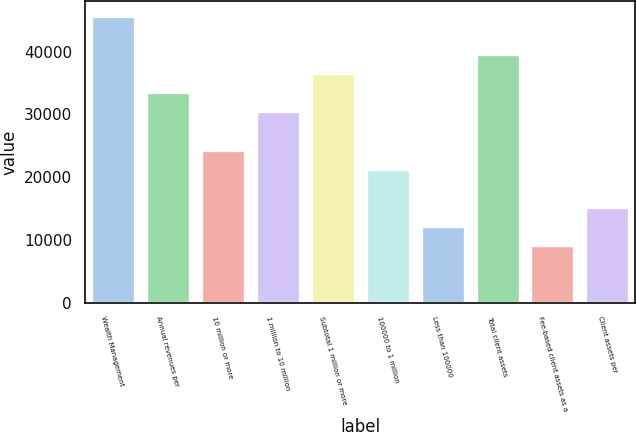<chart> <loc_0><loc_0><loc_500><loc_500><bar_chart><fcel>Wealth Management<fcel>Annual revenues per<fcel>10 million or more<fcel>1 million to 10 million<fcel>Subtotal 1 million or more<fcel>100000 to 1 million<fcel>Less than 100000<fcel>Total client assets<fcel>Fee-based client assets as a<fcel>Client assets per<nl><fcel>45755.2<fcel>33554.3<fcel>24403.6<fcel>30504<fcel>36604.5<fcel>21353.3<fcel>12202.6<fcel>39654.8<fcel>9152.36<fcel>15252.8<nl></chart> 